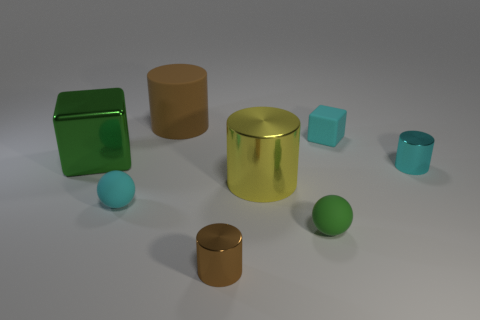Add 1 large metal things. How many objects exist? 9 Subtract all cubes. How many objects are left? 6 Add 8 cyan matte blocks. How many cyan matte blocks are left? 9 Add 6 large red blocks. How many large red blocks exist? 6 Subtract 1 cyan blocks. How many objects are left? 7 Subtract all big gray metal blocks. Subtract all large green metallic objects. How many objects are left? 7 